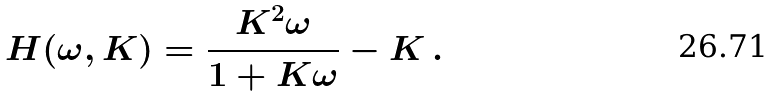Convert formula to latex. <formula><loc_0><loc_0><loc_500><loc_500>H ( \omega , K ) = \frac { K ^ { 2 } \omega } { 1 + K \omega } - K \, .</formula> 